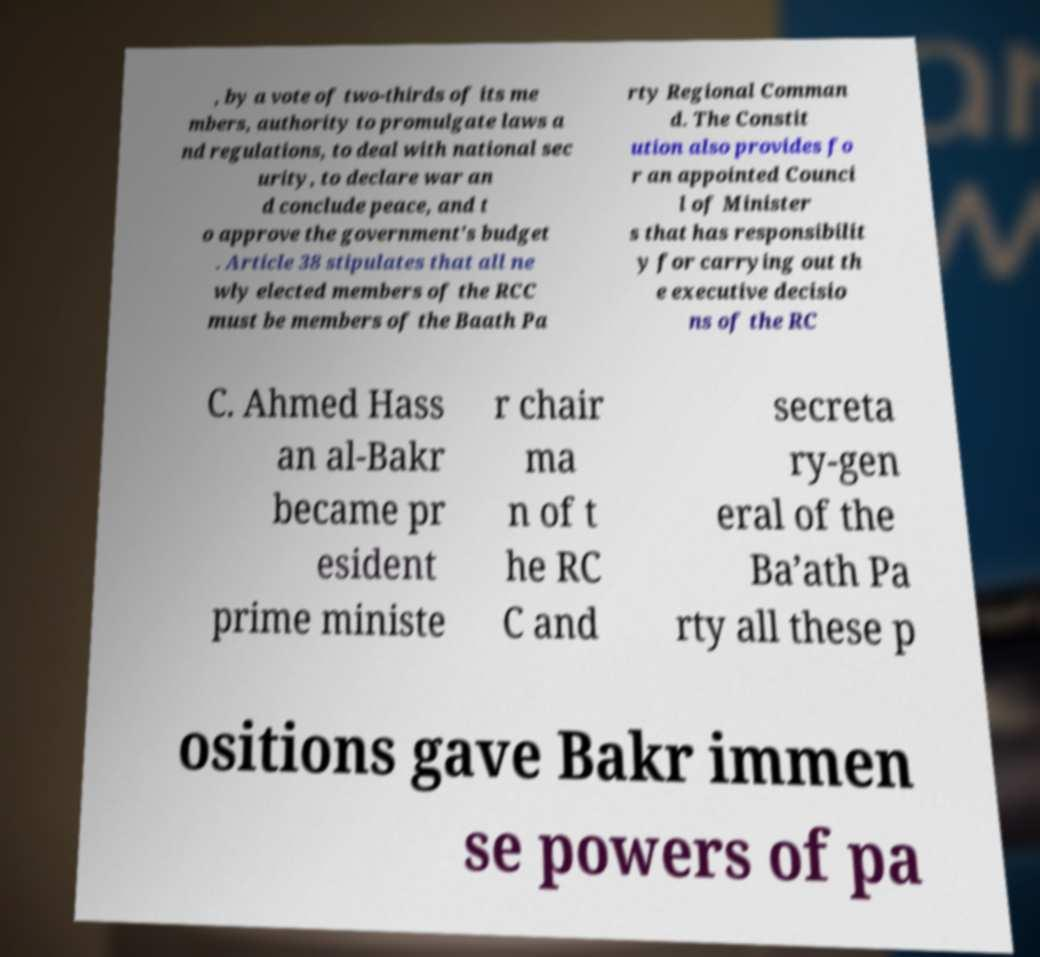For documentation purposes, I need the text within this image transcribed. Could you provide that? , by a vote of two-thirds of its me mbers, authority to promulgate laws a nd regulations, to deal with national sec urity, to declare war an d conclude peace, and t o approve the government's budget . Article 38 stipulates that all ne wly elected members of the RCC must be members of the Baath Pa rty Regional Comman d. The Constit ution also provides fo r an appointed Counci l of Minister s that has responsibilit y for carrying out th e executive decisio ns of the RC C. Ahmed Hass an al-Bakr became pr esident prime ministe r chair ma n of t he RC C and secreta ry-gen eral of the Ba’ath Pa rty all these p ositions gave Bakr immen se powers of pa 